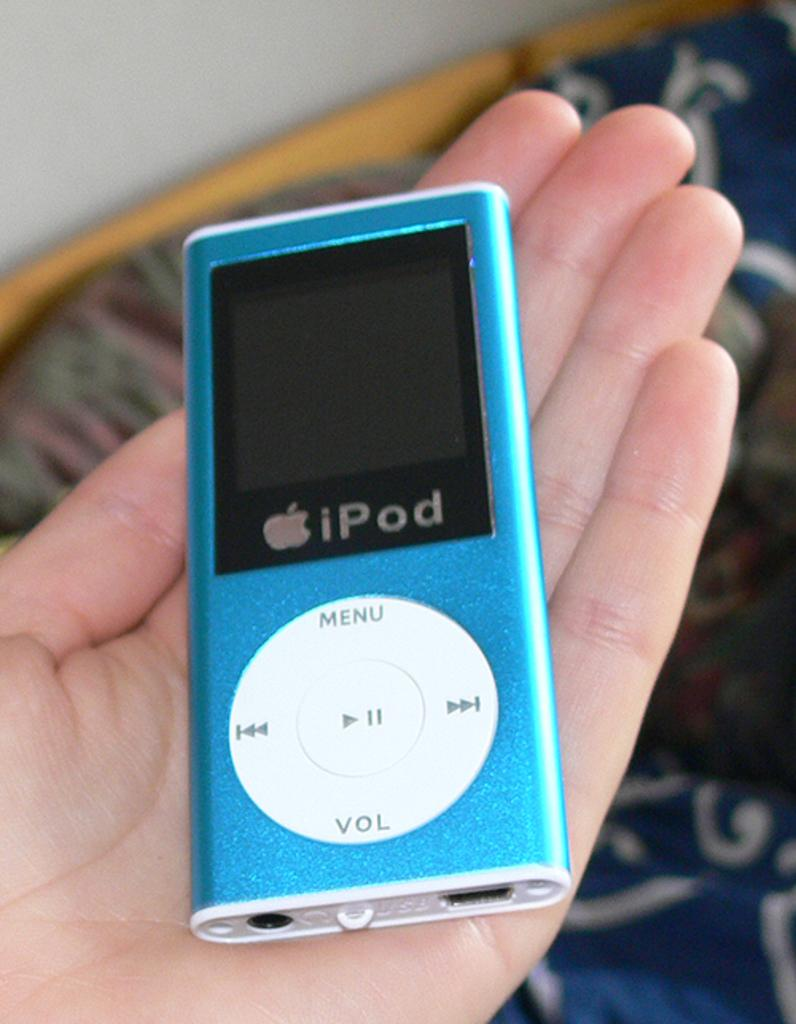What is the person holding in the image? There is a hand holding an iPod in the image. What else can be seen in the image besides the iPod? There is a bed in the image. What color is the bed sheet? The bed sheet is blue. What is the color of the wall in the image? There is a white wall in the image. What type of milk can be seen in the image? There is no milk present in the image. 